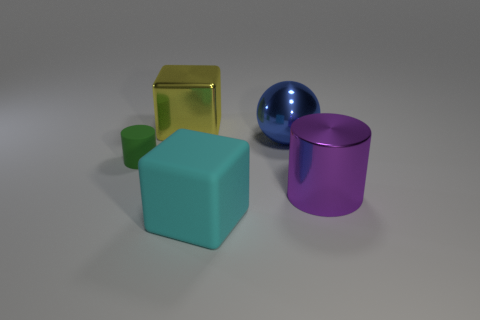Add 4 large blue things. How many objects exist? 9 Subtract all cylinders. How many objects are left? 3 Add 5 purple shiny things. How many purple shiny things are left? 6 Add 2 tiny green shiny cylinders. How many tiny green shiny cylinders exist? 2 Subtract 0 red cylinders. How many objects are left? 5 Subtract all tiny purple metal things. Subtract all rubber blocks. How many objects are left? 4 